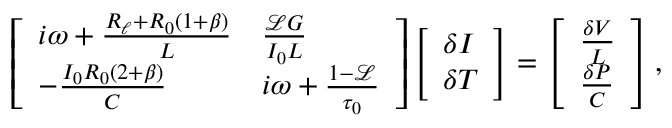<formula> <loc_0><loc_0><loc_500><loc_500>\left [ \begin{array} { l l } { i \omega + \frac { R _ { \ell } + R _ { 0 } ( 1 + \beta ) } { L } } & { \frac { \ m a t h s c r { L } G } { I _ { 0 } L } } \\ { - \frac { I _ { 0 } R _ { 0 } ( 2 + \beta ) } { C } } & { i \omega + \frac { 1 - \ m a t h s c r { L } } { \tau _ { 0 } } } \end{array} \right ] \left [ \begin{array} { l } { \delta I } \\ { \delta T } \end{array} \right ] = \left [ \begin{array} { l } { \frac { \delta V } { L } } \\ { \frac { \delta P } { C } } \end{array} \right ] ,</formula> 